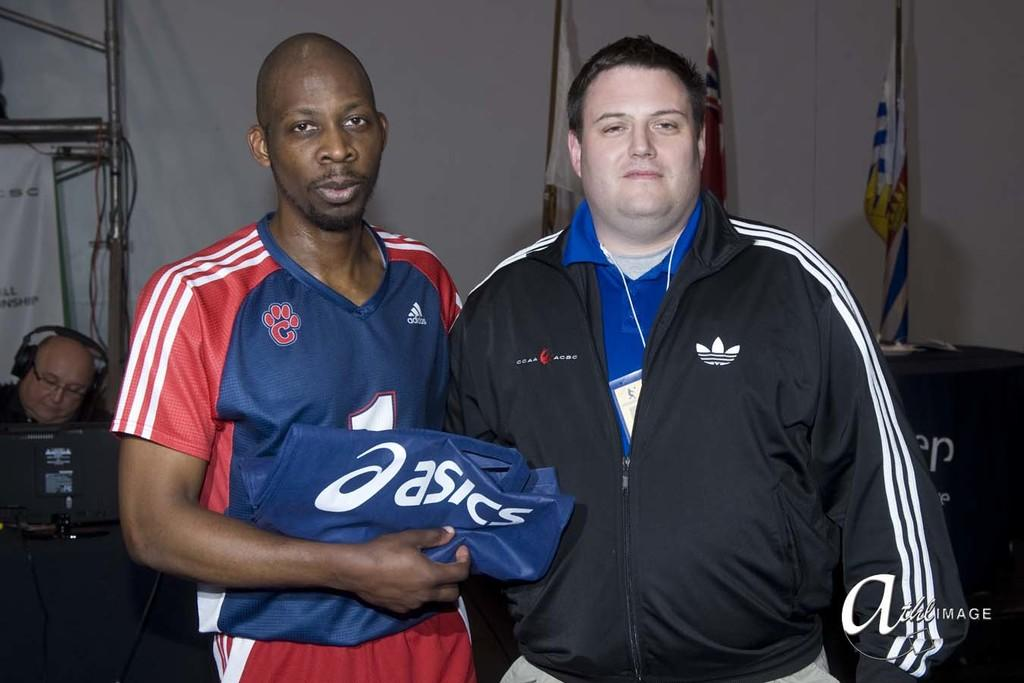<image>
Describe the image concisely. A Caucasian man wearing a black Adidas jacket and an African American man hold an Aasics brand item, are standing together for a photo. 